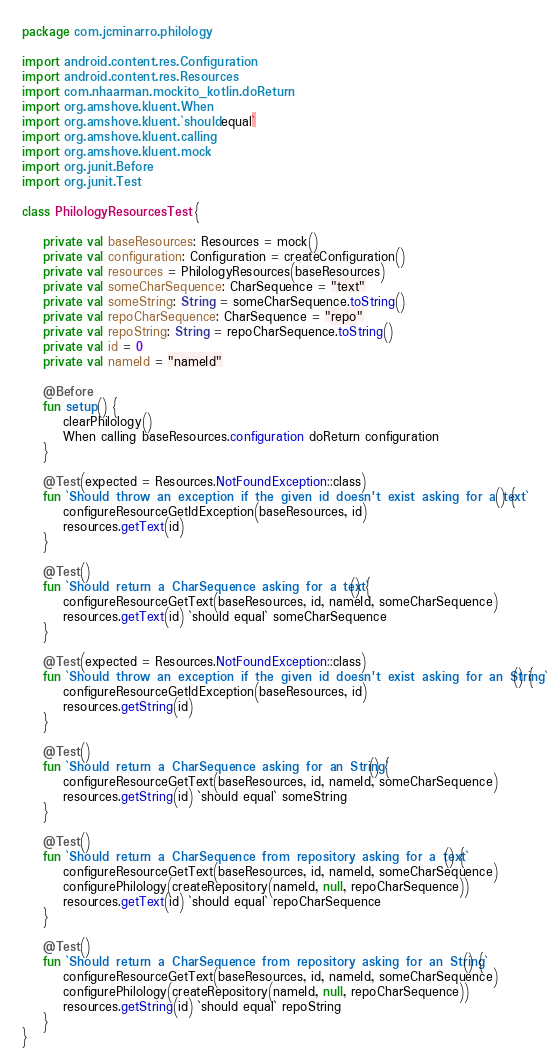<code> <loc_0><loc_0><loc_500><loc_500><_Kotlin_>package com.jcminarro.philology

import android.content.res.Configuration
import android.content.res.Resources
import com.nhaarman.mockito_kotlin.doReturn
import org.amshove.kluent.When
import org.amshove.kluent.`should equal`
import org.amshove.kluent.calling
import org.amshove.kluent.mock
import org.junit.Before
import org.junit.Test

class PhilologyResourcesTest {

    private val baseResources: Resources = mock()
    private val configuration: Configuration = createConfiguration()
    private val resources = PhilologyResources(baseResources)
    private val someCharSequence: CharSequence = "text"
    private val someString: String = someCharSequence.toString()
    private val repoCharSequence: CharSequence = "repo"
    private val repoString: String = repoCharSequence.toString()
    private val id = 0
    private val nameId = "nameId"

    @Before
    fun setup() {
        clearPhilology()
        When calling baseResources.configuration doReturn configuration
    }

    @Test(expected = Resources.NotFoundException::class)
    fun `Should throw an exception if the given id doesn't exist asking for a text`() {
        configureResourceGetIdException(baseResources, id)
        resources.getText(id)
    }

    @Test()
    fun `Should return a CharSequence asking for a text`() {
        configureResourceGetText(baseResources, id, nameId, someCharSequence)
        resources.getText(id) `should equal` someCharSequence
    }

    @Test(expected = Resources.NotFoundException::class)
    fun `Should throw an exception if the given id doesn't exist asking for an String`() {
        configureResourceGetIdException(baseResources, id)
        resources.getString(id)
    }

    @Test()
    fun `Should return a CharSequence asking for an String`() {
        configureResourceGetText(baseResources, id, nameId, someCharSequence)
        resources.getString(id) `should equal` someString
    }

    @Test()
    fun `Should return a CharSequence from repository asking for a text`() {
        configureResourceGetText(baseResources, id, nameId, someCharSequence)
        configurePhilology(createRepository(nameId, null, repoCharSequence))
        resources.getText(id) `should equal` repoCharSequence
    }

    @Test()
    fun `Should return a CharSequence from repository asking for an String`() {
        configureResourceGetText(baseResources, id, nameId, someCharSequence)
        configurePhilology(createRepository(nameId, null, repoCharSequence))
        resources.getString(id) `should equal` repoString
    }
}</code> 